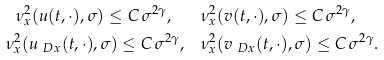Convert formula to latex. <formula><loc_0><loc_0><loc_500><loc_500>\nu ^ { 2 } _ { x } ( u ( t , \cdot ) , \sigma ) \leq C \, \sigma ^ { 2 \gamma } , \quad & \nu ^ { 2 } _ { x } ( v ( t , \cdot ) , \sigma ) \leq C \, \sigma ^ { 2 \gamma } , \\ \nu ^ { 2 } _ { x } ( u _ { \ D x } ( t , \cdot ) , \sigma ) \leq C \, \sigma ^ { 2 \gamma } , \quad & \nu ^ { 2 } _ { x } ( v _ { \ D x } ( t , \cdot ) , \sigma ) \leq C \, \sigma ^ { 2 \gamma } .</formula> 